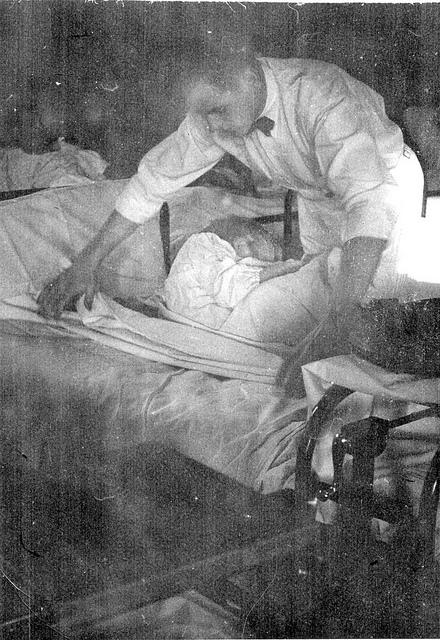Does he wear a bow tie?
Short answer required. Yes. Does the man appear to be wearing a work uniform?
Quick response, please. Yes. Does this look like it is from an old movie?
Keep it brief. Yes. 